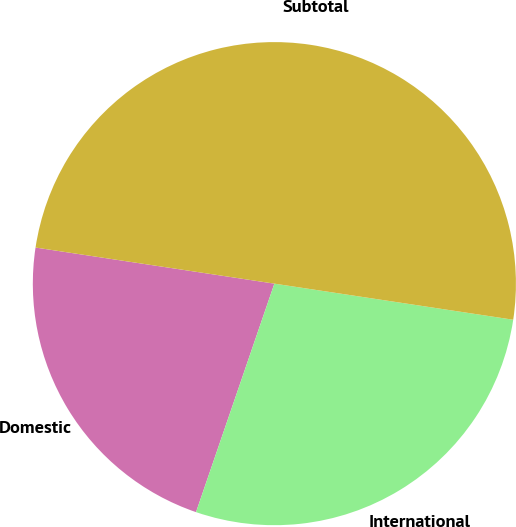<chart> <loc_0><loc_0><loc_500><loc_500><pie_chart><fcel>Domestic<fcel>International<fcel>Subtotal<nl><fcel>22.13%<fcel>27.87%<fcel>50.0%<nl></chart> 